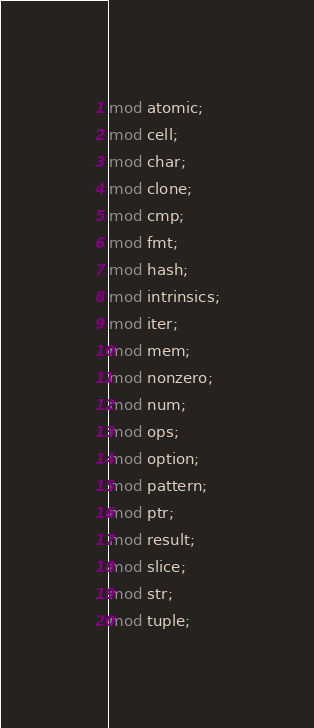<code> <loc_0><loc_0><loc_500><loc_500><_Rust_>mod atomic;
mod cell;
mod char;
mod clone;
mod cmp;
mod fmt;
mod hash;
mod intrinsics;
mod iter;
mod mem;
mod nonzero;
mod num;
mod ops;
mod option;
mod pattern;
mod ptr;
mod result;
mod slice;
mod str;
mod tuple;
</code> 